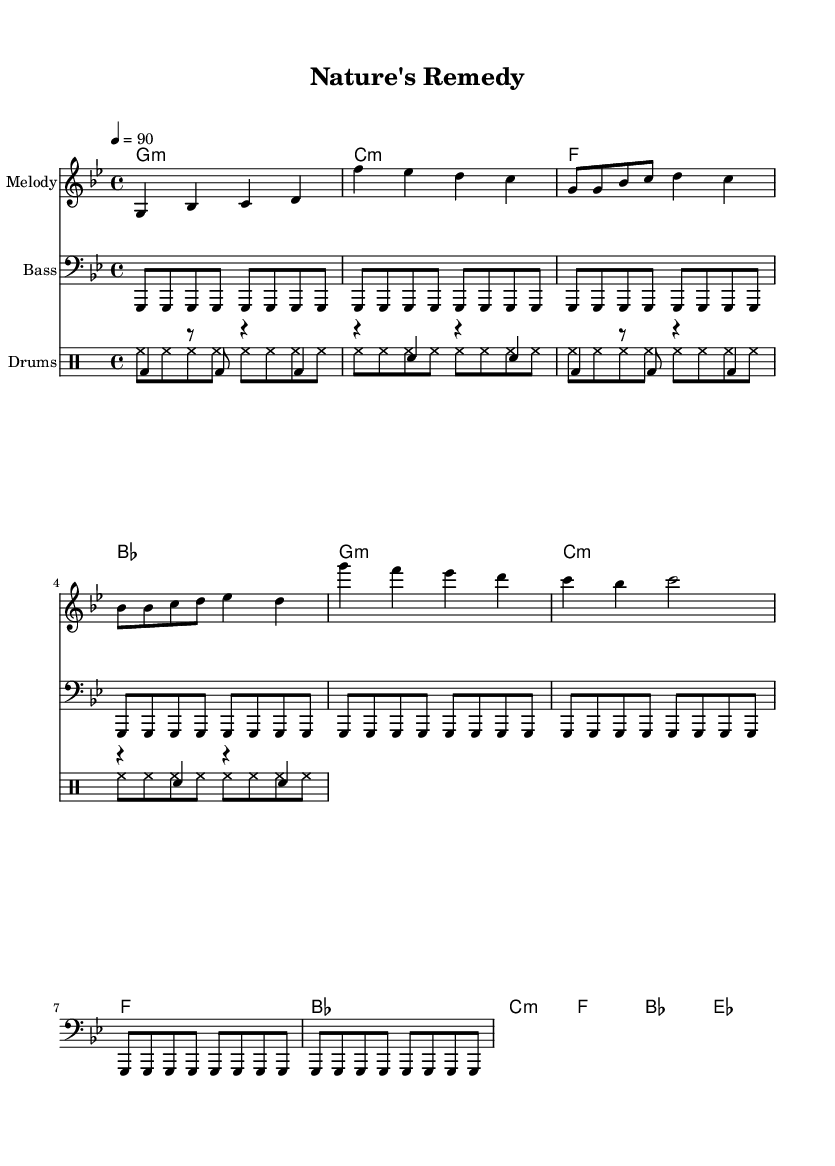What is the key signature of this music? The key signature is G minor, which has two flats: B flat and E flat.
Answer: G minor What is the time signature of this piece? The time signature is 4/4, indicating four beats in each measure.
Answer: 4/4 What is the tempo marking for the piece? The tempo marking is 90 beats per minute, indicated as "4 = 90".
Answer: 90 How many measures are in the verse section? The verse section consists of four measures, as visible within the melody and harmony part.
Answer: 4 What is the main theme of the chorus? The main theme of the chorus emphasizes the benefits of fresh, organic produce, urging awareness and appreciation.
Answer: Nature's remedy Which instruments are included in this score? The instruments included are Melody, Bass, and Drums, providing a complete hip hop ensemble setup.
Answer: Melody, Bass, Drums What type of drum patterns are featured in this music? The drum patterns include both pitched (bass and snare) and unpitched (hi-hats) sections, creating a varied rhythmic texture.
Answer: Pitched and unpitched 